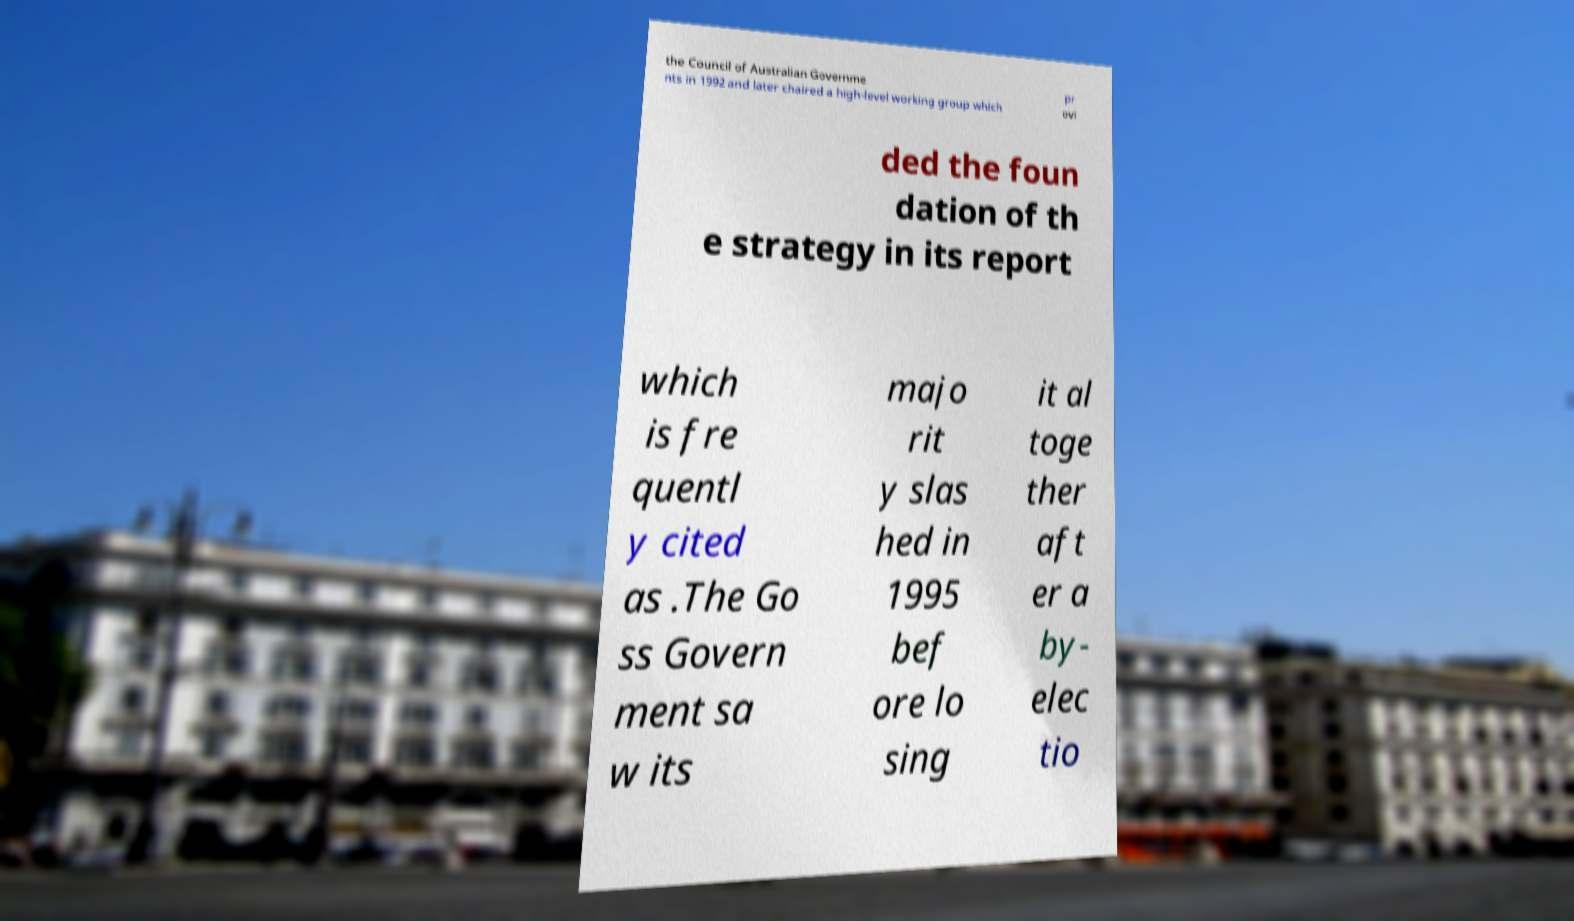Please read and relay the text visible in this image. What does it say? the Council of Australian Governme nts in 1992 and later chaired a high-level working group which pr ovi ded the foun dation of th e strategy in its report which is fre quentl y cited as .The Go ss Govern ment sa w its majo rit y slas hed in 1995 bef ore lo sing it al toge ther aft er a by- elec tio 